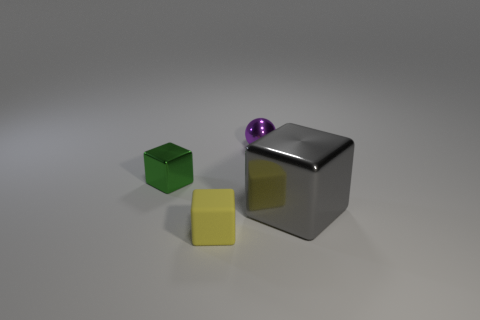There is a tiny yellow thing; are there any matte things on the right side of it?
Make the answer very short. No. Is there a tiny cube made of the same material as the gray thing?
Ensure brevity in your answer.  Yes. The tiny shiny ball is what color?
Provide a succinct answer. Purple. There is a object that is in front of the large block; is its shape the same as the small purple object?
Provide a succinct answer. No. There is a gray thing right of the tiny block right of the metal block that is behind the gray shiny object; what is its shape?
Offer a terse response. Cube. What material is the object that is right of the purple shiny sphere?
Ensure brevity in your answer.  Metal. What is the color of the other metal object that is the same size as the green shiny object?
Give a very brief answer. Purple. How many other things are there of the same shape as the large gray object?
Offer a terse response. 2. Is the gray thing the same size as the rubber cube?
Provide a short and direct response. No. Is the number of small objects in front of the green shiny cube greater than the number of small cubes behind the metallic sphere?
Keep it short and to the point. Yes. 